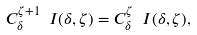Convert formula to latex. <formula><loc_0><loc_0><loc_500><loc_500>C ^ { \zeta + 1 } _ { \delta } \ I ( \delta , \zeta ) = C ^ { \zeta } _ { \delta } \ I ( \delta , \zeta ) ,</formula> 